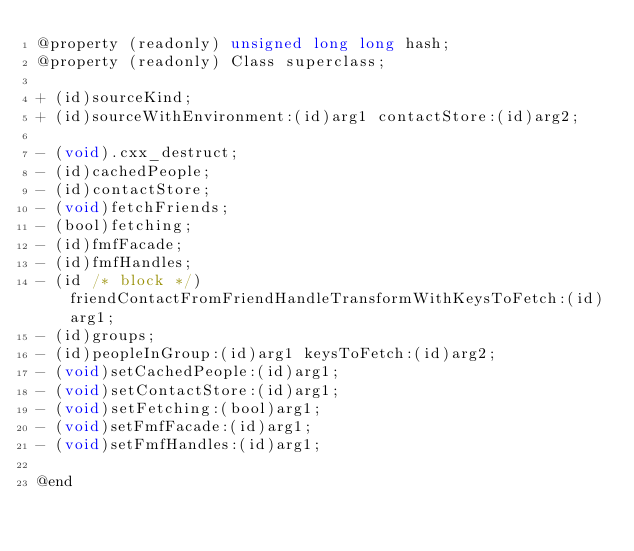<code> <loc_0><loc_0><loc_500><loc_500><_C_>@property (readonly) unsigned long long hash;
@property (readonly) Class superclass;

+ (id)sourceKind;
+ (id)sourceWithEnvironment:(id)arg1 contactStore:(id)arg2;

- (void).cxx_destruct;
- (id)cachedPeople;
- (id)contactStore;
- (void)fetchFriends;
- (bool)fetching;
- (id)fmfFacade;
- (id)fmfHandles;
- (id /* block */)friendContactFromFriendHandleTransformWithKeysToFetch:(id)arg1;
- (id)groups;
- (id)peopleInGroup:(id)arg1 keysToFetch:(id)arg2;
- (void)setCachedPeople:(id)arg1;
- (void)setContactStore:(id)arg1;
- (void)setFetching:(bool)arg1;
- (void)setFmfFacade:(id)arg1;
- (void)setFmfHandles:(id)arg1;

@end
</code> 